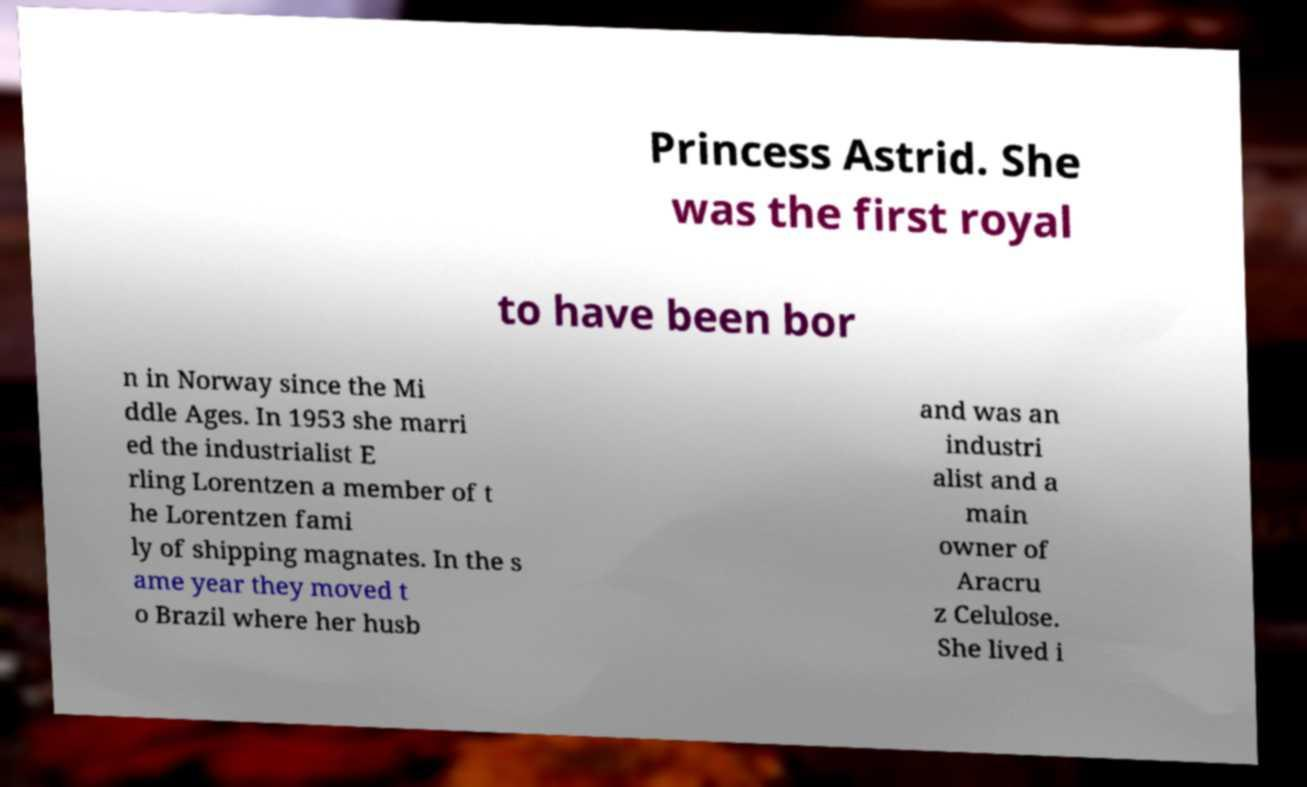Please identify and transcribe the text found in this image. Princess Astrid. She was the first royal to have been bor n in Norway since the Mi ddle Ages. In 1953 she marri ed the industrialist E rling Lorentzen a member of t he Lorentzen fami ly of shipping magnates. In the s ame year they moved t o Brazil where her husb and was an industri alist and a main owner of Aracru z Celulose. She lived i 